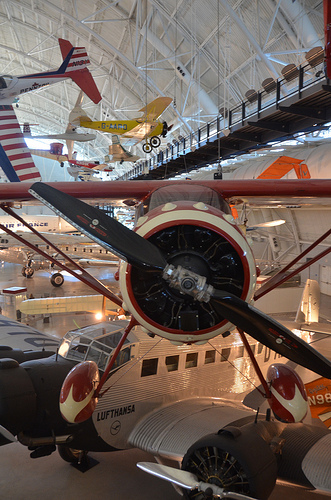<image>
Can you confirm if the airplane is behind the airplane? No. The airplane is not behind the airplane. From this viewpoint, the airplane appears to be positioned elsewhere in the scene. 